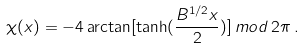<formula> <loc_0><loc_0><loc_500><loc_500>\chi ( x ) = - 4 \arctan [ \tanh ( \frac { B ^ { 1 / 2 } x } { 2 } ) ] \, m o d \, 2 \pi \, .</formula> 